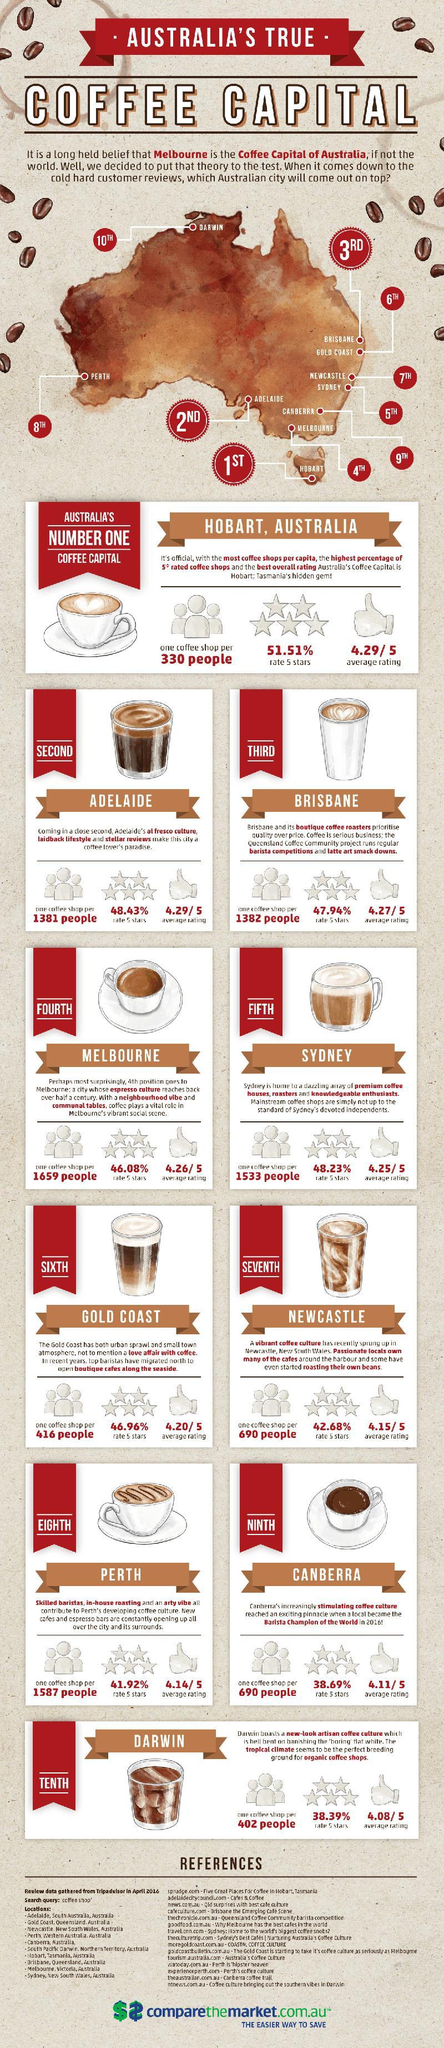Which is the isolated city that is the best coffee spot in Australia?
Answer the question with a short phrase. Hobart Which city holds the third place in coffee customer reviews? BRISBANE How many coffee cups, mugs and glasses are shown in the infographic? 10 Which city has one coffee shop per 1659 people? Melbourne How many references are cited? 15 